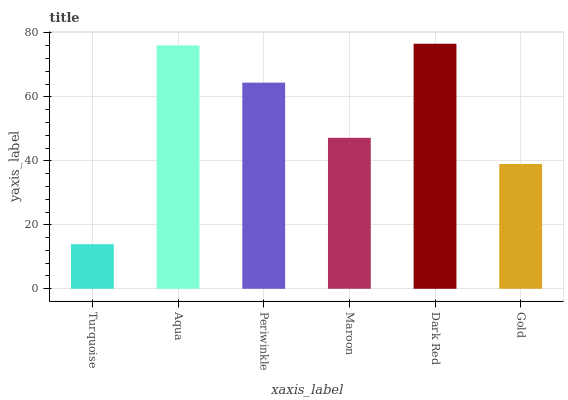Is Turquoise the minimum?
Answer yes or no. Yes. Is Dark Red the maximum?
Answer yes or no. Yes. Is Aqua the minimum?
Answer yes or no. No. Is Aqua the maximum?
Answer yes or no. No. Is Aqua greater than Turquoise?
Answer yes or no. Yes. Is Turquoise less than Aqua?
Answer yes or no. Yes. Is Turquoise greater than Aqua?
Answer yes or no. No. Is Aqua less than Turquoise?
Answer yes or no. No. Is Periwinkle the high median?
Answer yes or no. Yes. Is Maroon the low median?
Answer yes or no. Yes. Is Maroon the high median?
Answer yes or no. No. Is Periwinkle the low median?
Answer yes or no. No. 